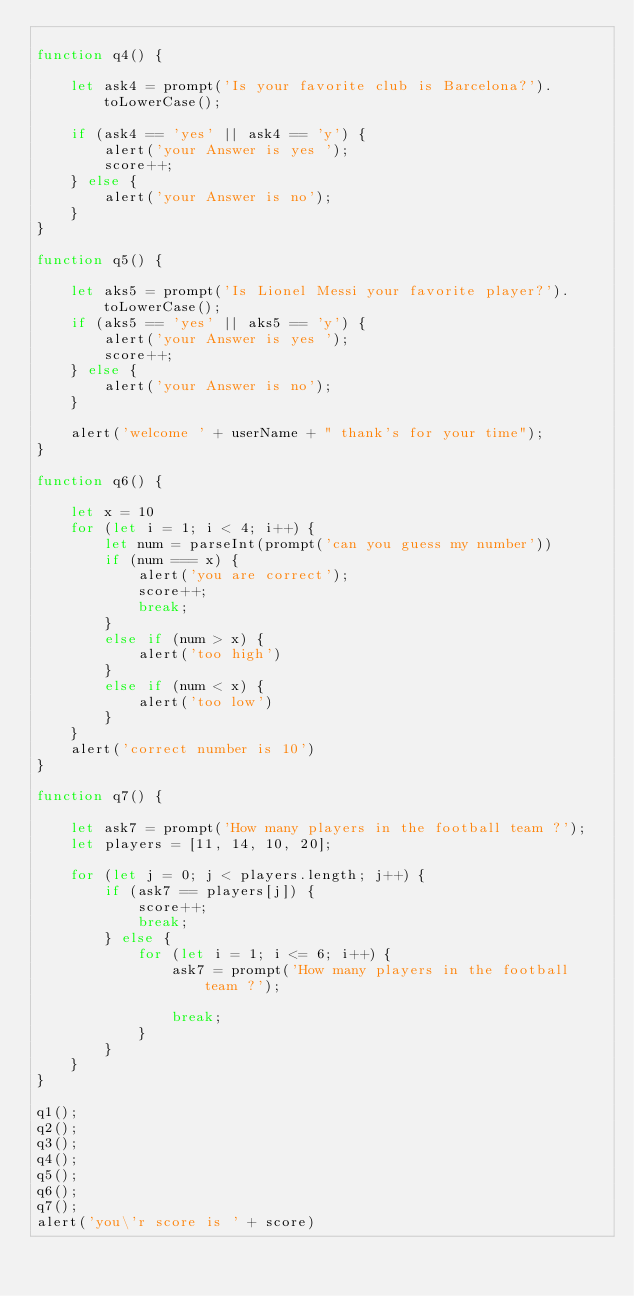Convert code to text. <code><loc_0><loc_0><loc_500><loc_500><_JavaScript_>
function q4() {

    let ask4 = prompt('Is your favorite club is Barcelona?').toLowerCase();
    
    if (ask4 == 'yes' || ask4 == 'y') {
        alert('your Answer is yes ');
        score++;
    } else {
        alert('your Answer is no');
    }
}

function q5() {

    let aks5 = prompt('Is Lionel Messi your favorite player?').toLowerCase();
    if (aks5 == 'yes' || aks5 == 'y') {
        alert('your Answer is yes ');
        score++;
    } else {
        alert('your Answer is no');
    }

    alert('welcome ' + userName + " thank's for your time");
}

function q6() {

    let x = 10
    for (let i = 1; i < 4; i++) {
        let num = parseInt(prompt('can you guess my number'))
        if (num === x) {
            alert('you are correct');
            score++;
            break;
        }
        else if (num > x) {
            alert('too high')
        }
        else if (num < x) {
            alert('too low')
        }
    }
    alert('correct number is 10')
}

function q7() {

    let ask7 = prompt('How many players in the football team ?');
    let players = [11, 14, 10, 20];

    for (let j = 0; j < players.length; j++) {
        if (ask7 == players[j]) {
            score++;
            break;
        } else {
            for (let i = 1; i <= 6; i++) {
                ask7 = prompt('How many players in the football team ?');

                break;
            }
        }
    }
}

q1();
q2();
q3();
q4();
q5();
q6();
q7();
alert('you\'r score is ' + score)


</code> 